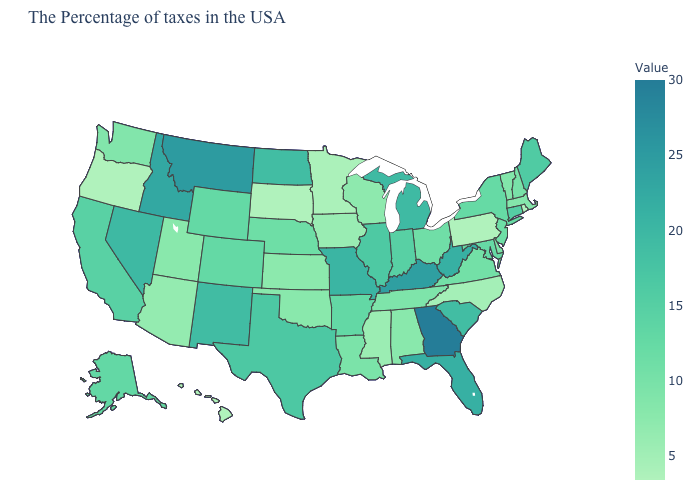Does the map have missing data?
Concise answer only. No. Is the legend a continuous bar?
Write a very short answer. Yes. Among the states that border Nevada , does Oregon have the lowest value?
Quick response, please. Yes. Among the states that border Texas , which have the lowest value?
Give a very brief answer. Oklahoma. Which states have the highest value in the USA?
Short answer required. Georgia. Does Maine have the lowest value in the USA?
Write a very short answer. No. 